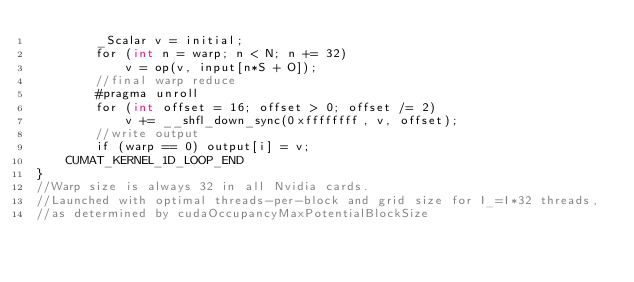<code> <loc_0><loc_0><loc_500><loc_500><_Cuda_>		_Scalar v = initial;
		for (int n = warp; n < N; n += 32)
			v = op(v, input[n*S + O]);
		//final warp reduce
		#pragma unroll
		for (int offset = 16; offset > 0; offset /= 2)
			v += __shfl_down_sync(0xffffffff, v, offset);
		//write output
		if (warp == 0) output[i] = v;
	CUMAT_KERNEL_1D_LOOP_END
}
//Warp size is always 32 in all Nvidia cards.
//Launched with optimal threads-per-block and grid size for I_=I*32 threads, 
//as determined by cudaOccupancyMaxPotentialBlockSize</code> 